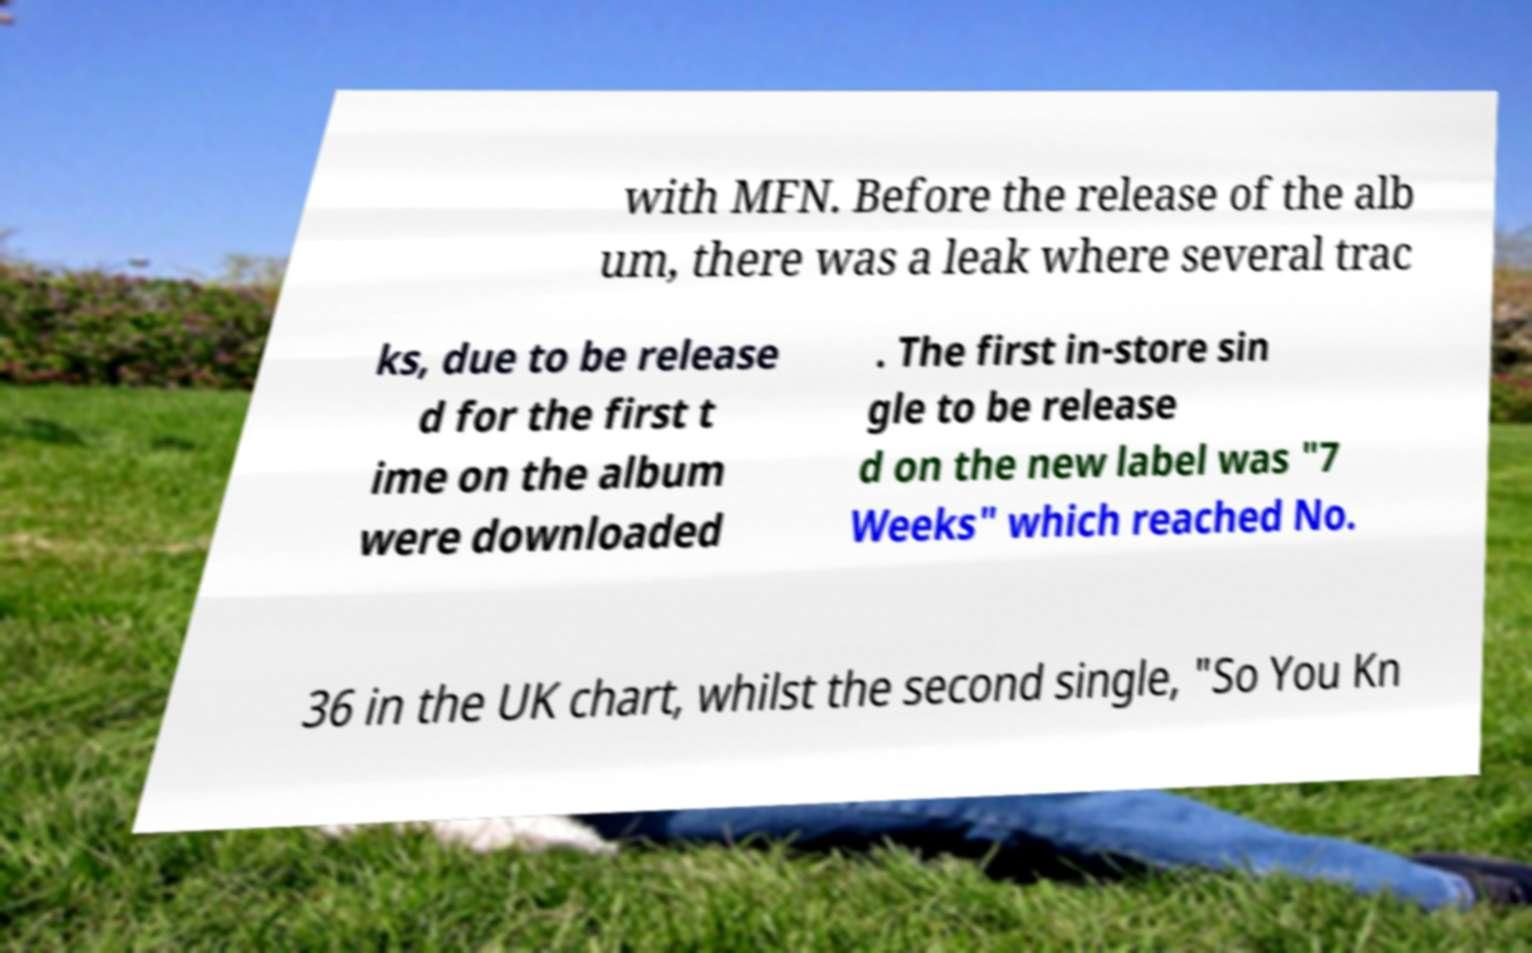What messages or text are displayed in this image? I need them in a readable, typed format. with MFN. Before the release of the alb um, there was a leak where several trac ks, due to be release d for the first t ime on the album were downloaded . The first in-store sin gle to be release d on the new label was "7 Weeks" which reached No. 36 in the UK chart, whilst the second single, "So You Kn 